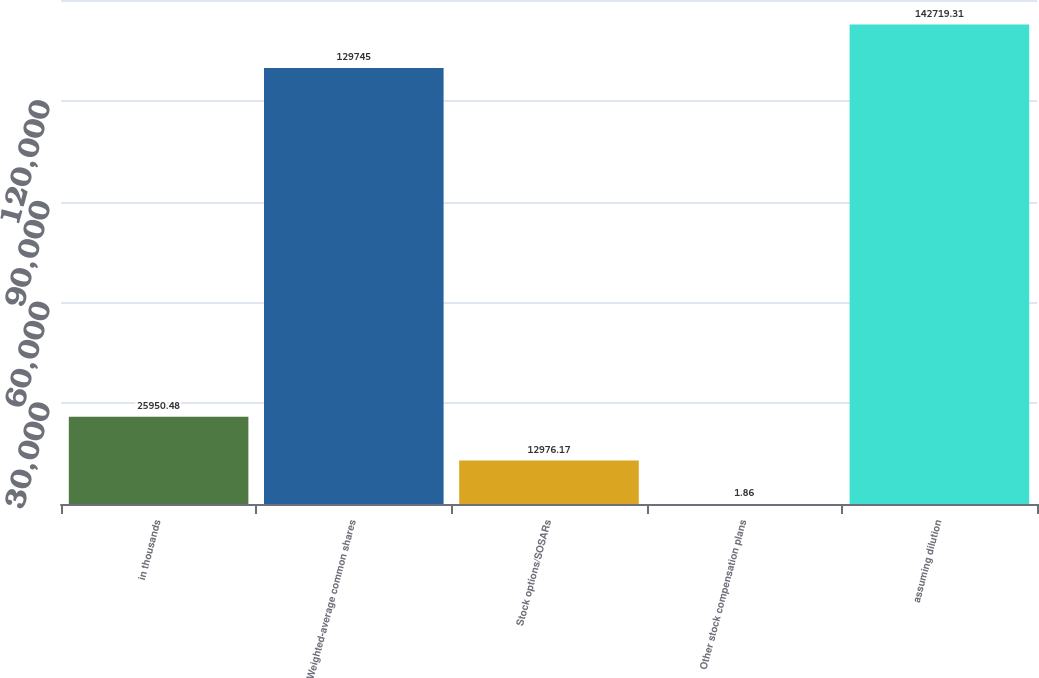<chart> <loc_0><loc_0><loc_500><loc_500><bar_chart><fcel>in thousands<fcel>Weighted-average common shares<fcel>Stock options/SOSARs<fcel>Other stock compensation plans<fcel>assuming dilution<nl><fcel>25950.5<fcel>129745<fcel>12976.2<fcel>1.86<fcel>142719<nl></chart> 